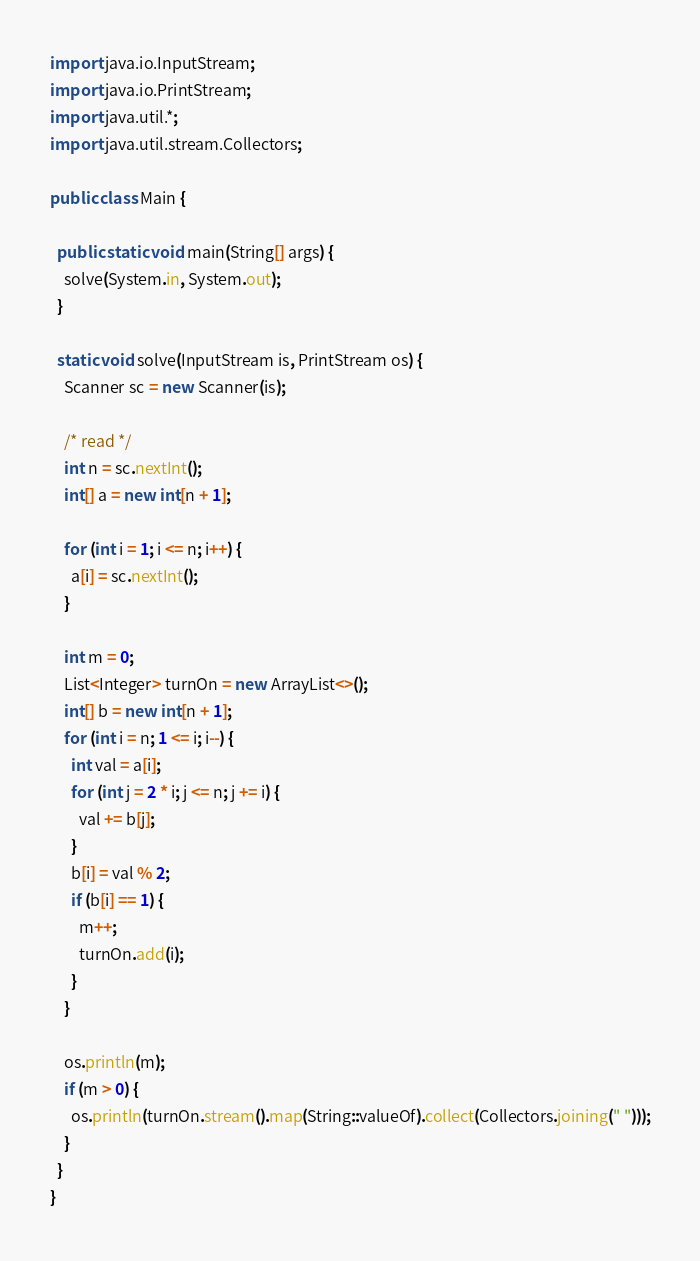Convert code to text. <code><loc_0><loc_0><loc_500><loc_500><_Java_>import java.io.InputStream;
import java.io.PrintStream;
import java.util.*;
import java.util.stream.Collectors;

public class Main {

  public static void main(String[] args) {
    solve(System.in, System.out);
  }

  static void solve(InputStream is, PrintStream os) {
    Scanner sc = new Scanner(is);

    /* read */
    int n = sc.nextInt();
    int[] a = new int[n + 1];

    for (int i = 1; i <= n; i++) {
      a[i] = sc.nextInt();
    }

    int m = 0;
    List<Integer> turnOn = new ArrayList<>();
    int[] b = new int[n + 1];
    for (int i = n; 1 <= i; i--) {
      int val = a[i];
      for (int j = 2 * i; j <= n; j += i) {
        val += b[j];
      }
      b[i] = val % 2;
      if (b[i] == 1) {
        m++;
        turnOn.add(i);
      }
    }

    os.println(m);
    if (m > 0) {
      os.println(turnOn.stream().map(String::valueOf).collect(Collectors.joining(" ")));
    }
  }
}</code> 